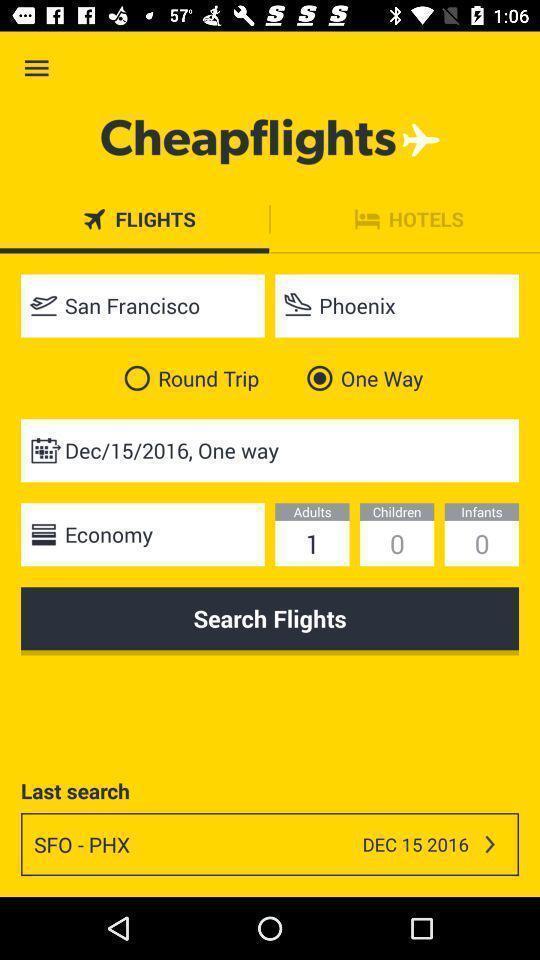Summarize the main components in this picture. Page requesting to enter details of journey on an app. 